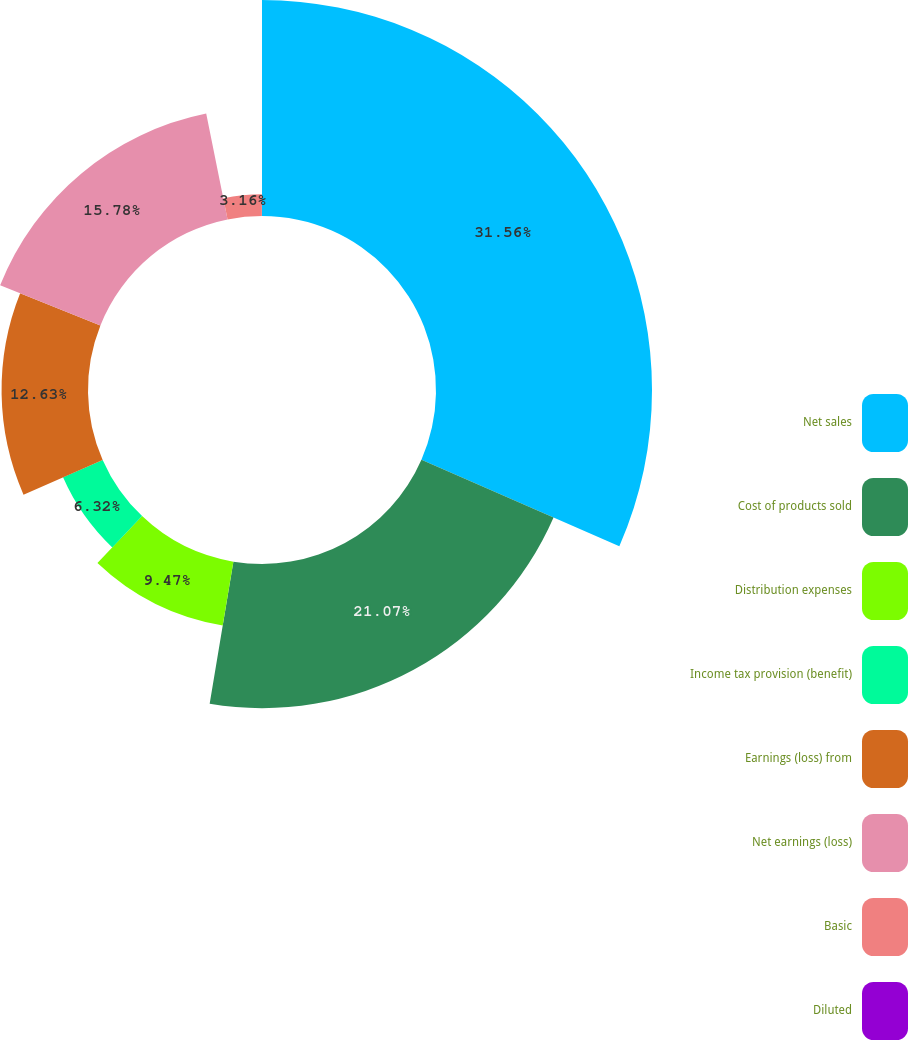<chart> <loc_0><loc_0><loc_500><loc_500><pie_chart><fcel>Net sales<fcel>Cost of products sold<fcel>Distribution expenses<fcel>Income tax provision (benefit)<fcel>Earnings (loss) from<fcel>Net earnings (loss)<fcel>Basic<fcel>Diluted<nl><fcel>31.56%<fcel>21.07%<fcel>9.47%<fcel>6.32%<fcel>12.63%<fcel>15.78%<fcel>3.16%<fcel>0.01%<nl></chart> 